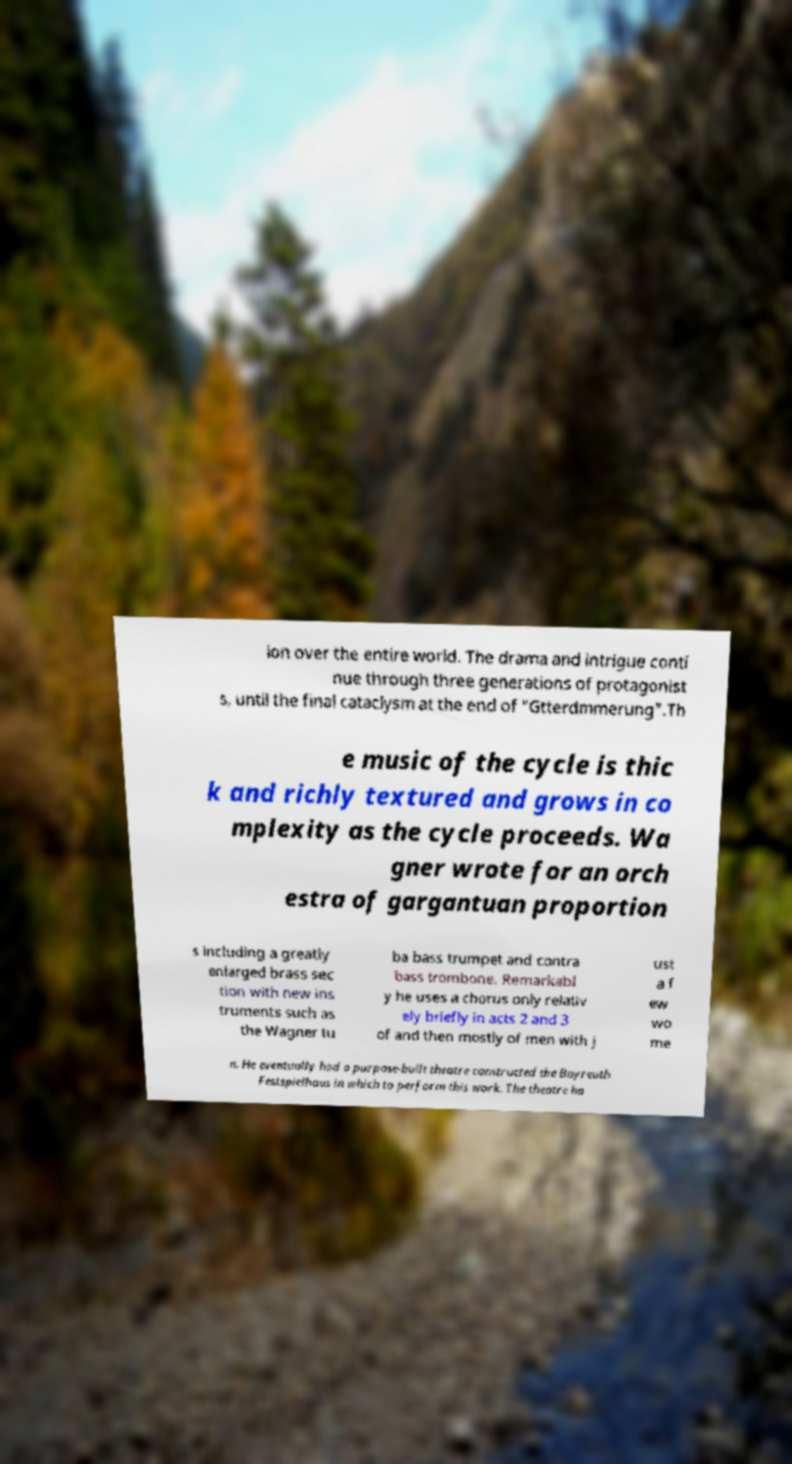Can you accurately transcribe the text from the provided image for me? ion over the entire world. The drama and intrigue conti nue through three generations of protagonist s, until the final cataclysm at the end of "Gtterdmmerung".Th e music of the cycle is thic k and richly textured and grows in co mplexity as the cycle proceeds. Wa gner wrote for an orch estra of gargantuan proportion s including a greatly enlarged brass sec tion with new ins truments such as the Wagner tu ba bass trumpet and contra bass trombone. Remarkabl y he uses a chorus only relativ ely briefly in acts 2 and 3 of and then mostly of men with j ust a f ew wo me n. He eventually had a purpose-built theatre constructed the Bayreuth Festspielhaus in which to perform this work. The theatre ha 